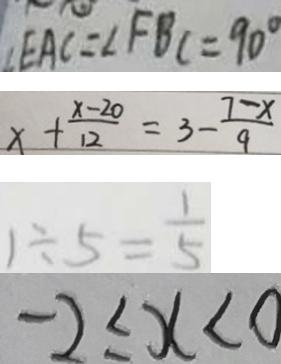<formula> <loc_0><loc_0><loc_500><loc_500>\angle E A C = \angle F B C = 9 0 ^ { \circ } 
 x + \frac { x - 2 0 } { 1 2 } = 3 - \frac { 7 - x } { 9 } 
 1 \div 5 = \frac { 1 } { 5 } 
 - 2 \leq x < 0</formula> 